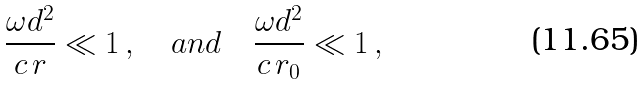<formula> <loc_0><loc_0><loc_500><loc_500>\frac { \omega d ^ { 2 } } { c \, r } \ll 1 \, , \quad a n d \quad \frac { \omega d ^ { 2 } } { c \, r _ { 0 } } \ll 1 \, ,</formula> 